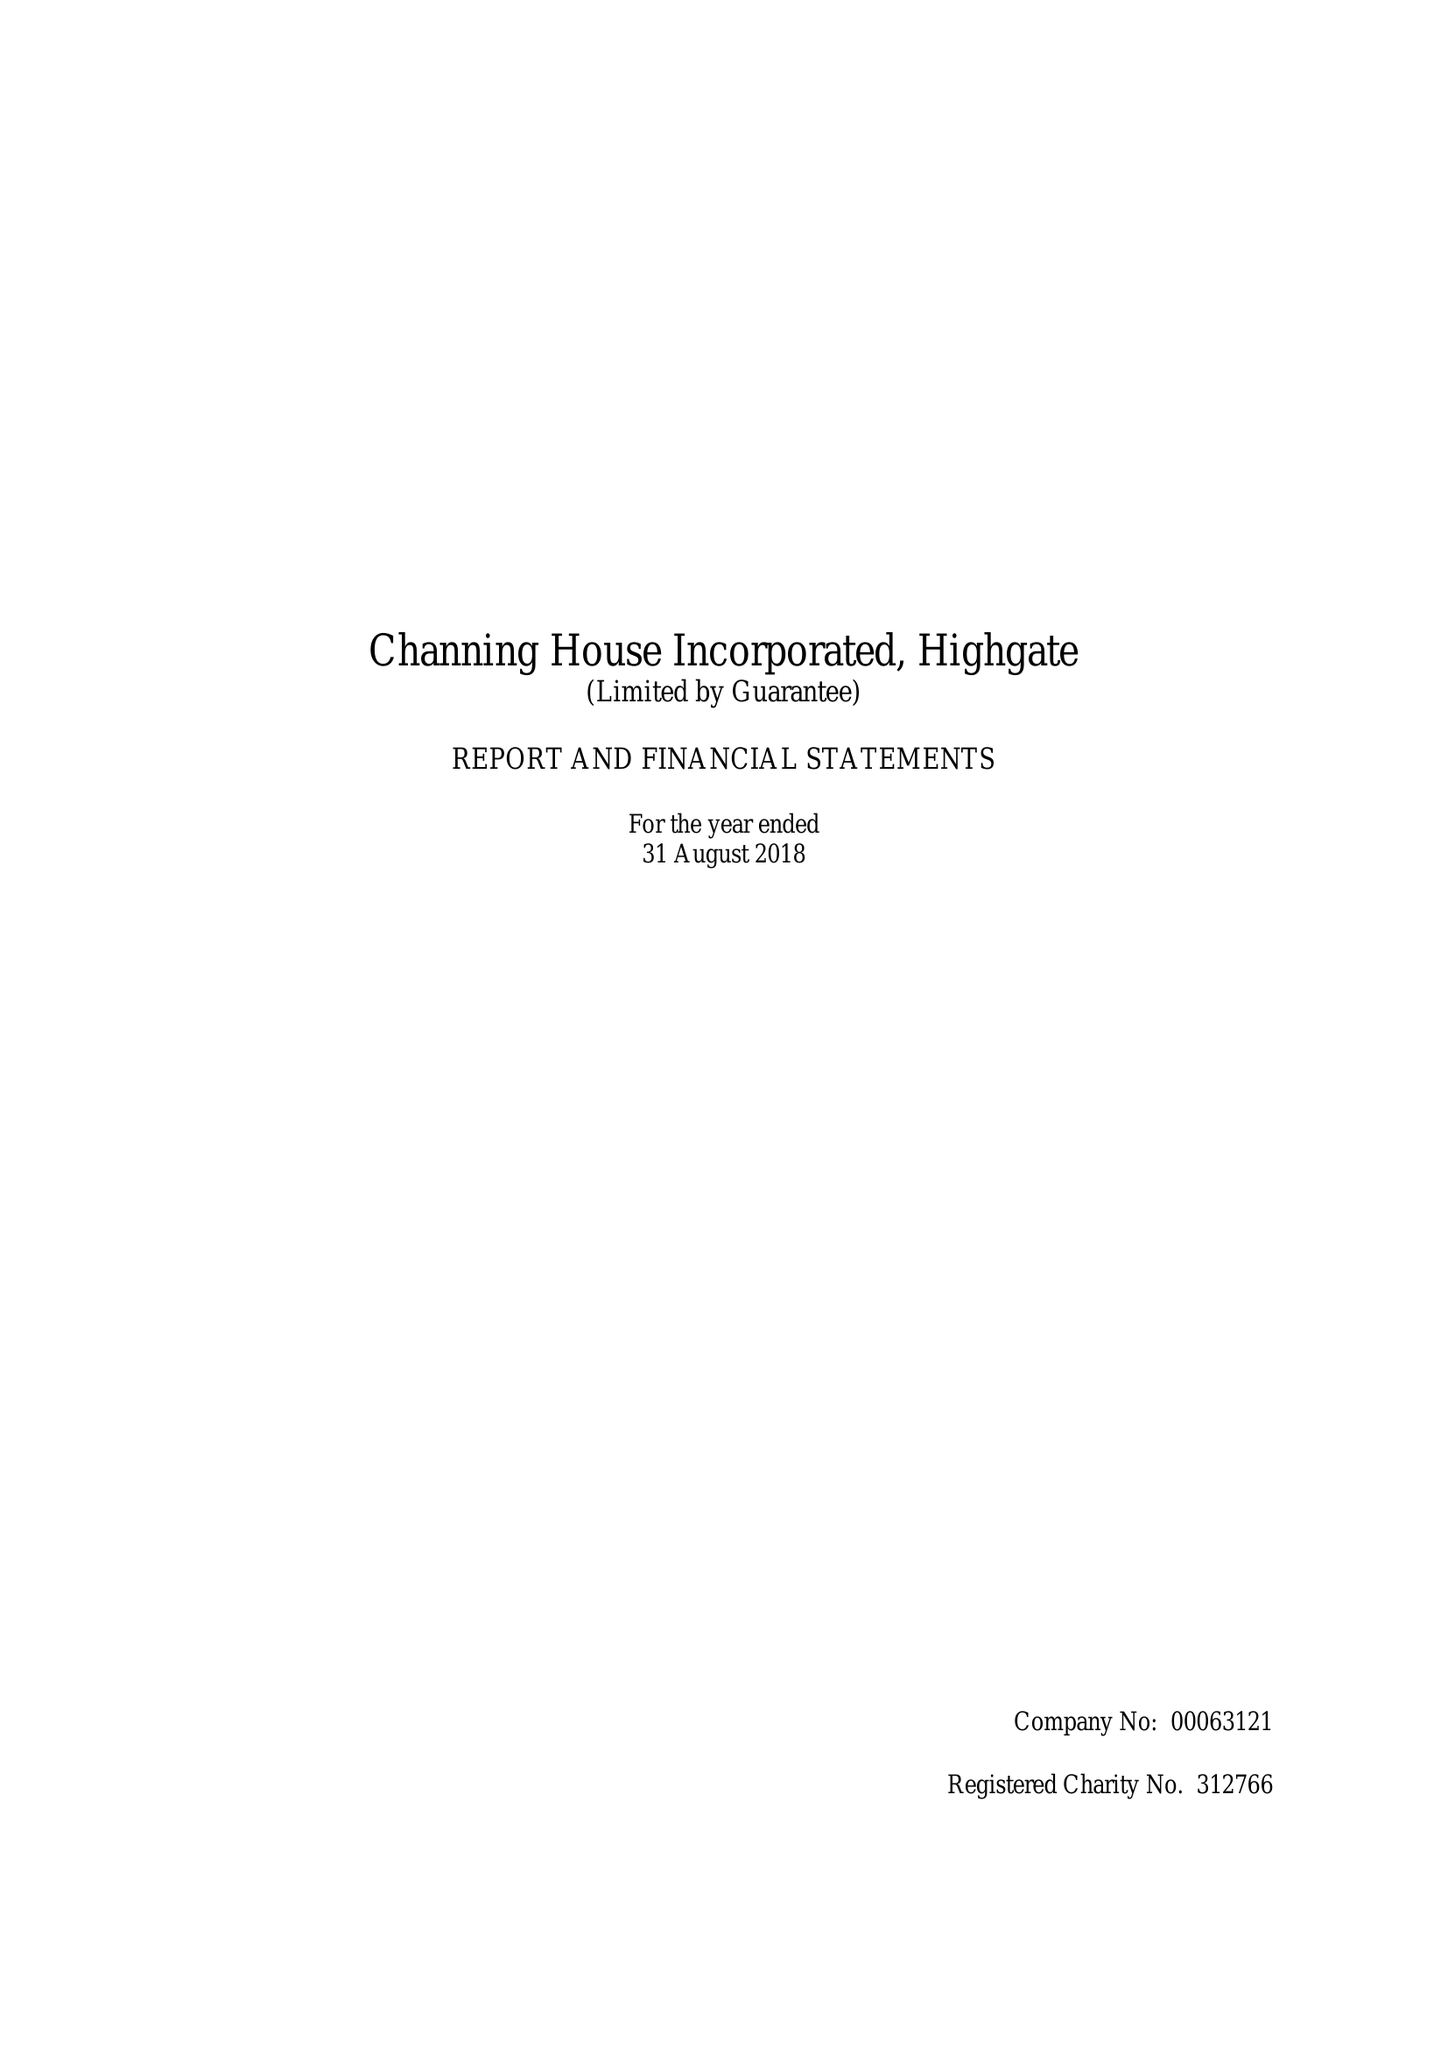What is the value for the income_annually_in_british_pounds?
Answer the question using a single word or phrase. 16943800.00 